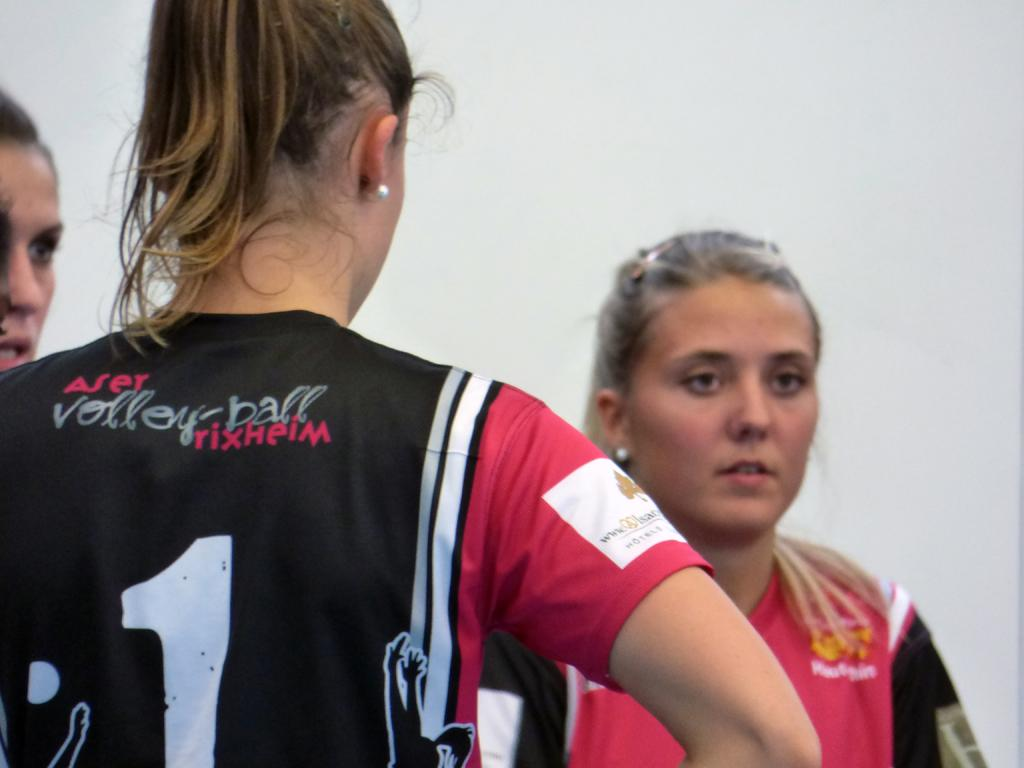<image>
Offer a succinct explanation of the picture presented. Three volleyball players are stood wearing black tops with Aser Volleyball written on them 